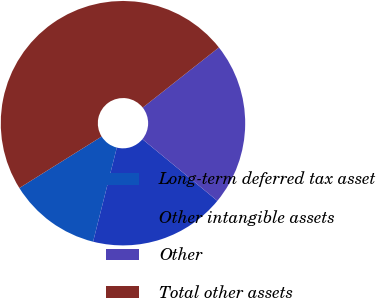Convert chart to OTSL. <chart><loc_0><loc_0><loc_500><loc_500><pie_chart><fcel>Long-term deferred tax asset<fcel>Other intangible assets<fcel>Other<fcel>Total other assets<nl><fcel>12.17%<fcel>17.98%<fcel>21.59%<fcel>48.26%<nl></chart> 